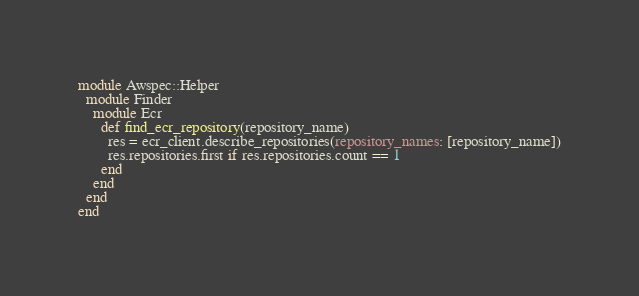Convert code to text. <code><loc_0><loc_0><loc_500><loc_500><_Ruby_>module Awspec::Helper
  module Finder
    module Ecr
      def find_ecr_repository(repository_name)
        res = ecr_client.describe_repositories(repository_names: [repository_name])
        res.repositories.first if res.repositories.count == 1
      end
    end
  end
end
</code> 